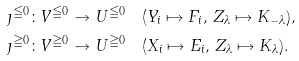Convert formula to latex. <formula><loc_0><loc_0><loc_500><loc_500>& \jmath ^ { \leqq 0 } \colon V ^ { \leqq 0 } \to U ^ { \leqq 0 } \quad ( Y _ { i } \mapsto F _ { i } , \, Z _ { \lambda } \mapsto K _ { - \lambda } ) , \\ & \jmath ^ { \geqq 0 } \colon V ^ { \geqq 0 } \to U ^ { \geqq 0 } \quad ( X _ { i } \mapsto E _ { i } , \, Z _ { \lambda } \mapsto K _ { \lambda } ) .</formula> 